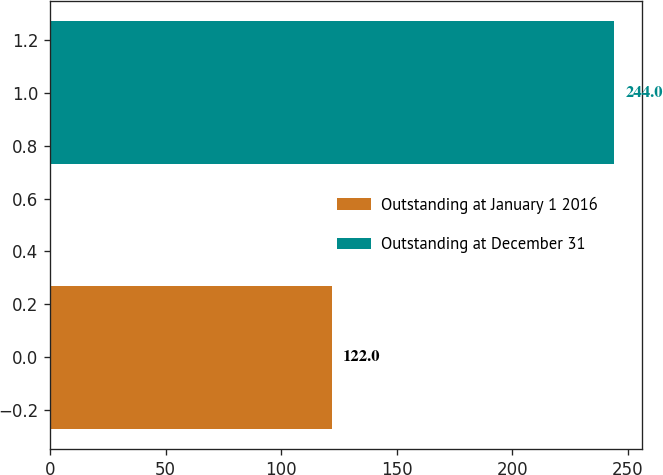<chart> <loc_0><loc_0><loc_500><loc_500><bar_chart><fcel>Outstanding at January 1 2016<fcel>Outstanding at December 31<nl><fcel>122<fcel>244<nl></chart> 